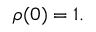<formula> <loc_0><loc_0><loc_500><loc_500>\rho ( { 0 } ) = 1 .</formula> 